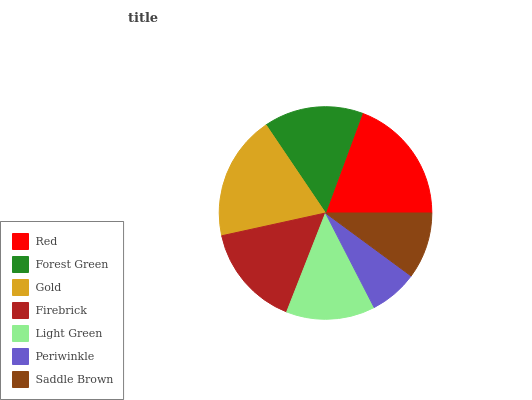Is Periwinkle the minimum?
Answer yes or no. Yes. Is Red the maximum?
Answer yes or no. Yes. Is Forest Green the minimum?
Answer yes or no. No. Is Forest Green the maximum?
Answer yes or no. No. Is Red greater than Forest Green?
Answer yes or no. Yes. Is Forest Green less than Red?
Answer yes or no. Yes. Is Forest Green greater than Red?
Answer yes or no. No. Is Red less than Forest Green?
Answer yes or no. No. Is Forest Green the high median?
Answer yes or no. Yes. Is Forest Green the low median?
Answer yes or no. Yes. Is Red the high median?
Answer yes or no. No. Is Red the low median?
Answer yes or no. No. 